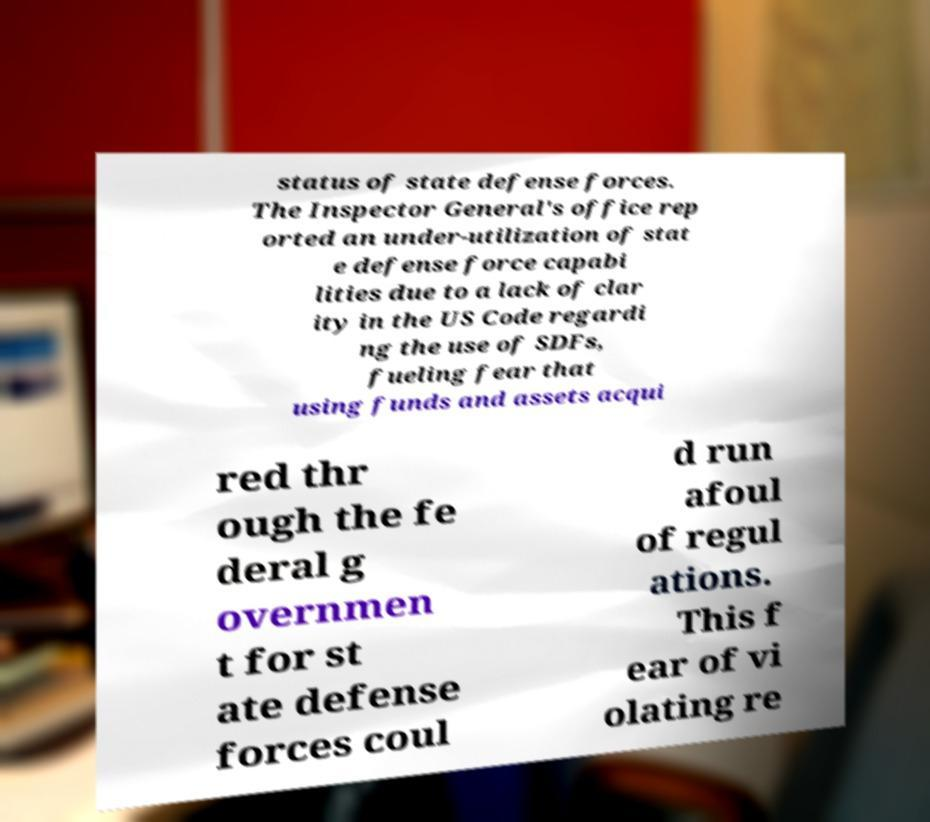I need the written content from this picture converted into text. Can you do that? status of state defense forces. The Inspector General's office rep orted an under-utilization of stat e defense force capabi lities due to a lack of clar ity in the US Code regardi ng the use of SDFs, fueling fear that using funds and assets acqui red thr ough the fe deral g overnmen t for st ate defense forces coul d run afoul of regul ations. This f ear of vi olating re 